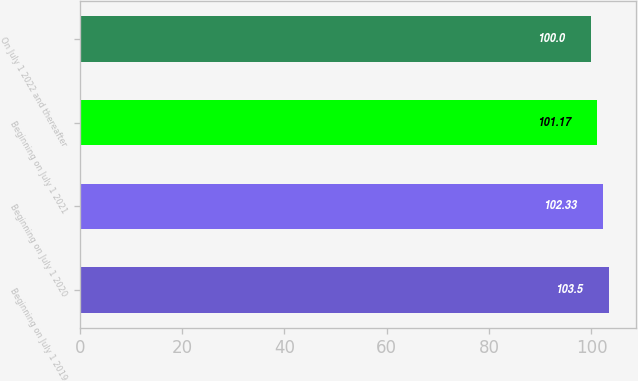Convert chart. <chart><loc_0><loc_0><loc_500><loc_500><bar_chart><fcel>Beginning on July 1 2019<fcel>Beginning on July 1 2020<fcel>Beginning on July 1 2021<fcel>On July 1 2022 and thereafter<nl><fcel>103.5<fcel>102.33<fcel>101.17<fcel>100<nl></chart> 